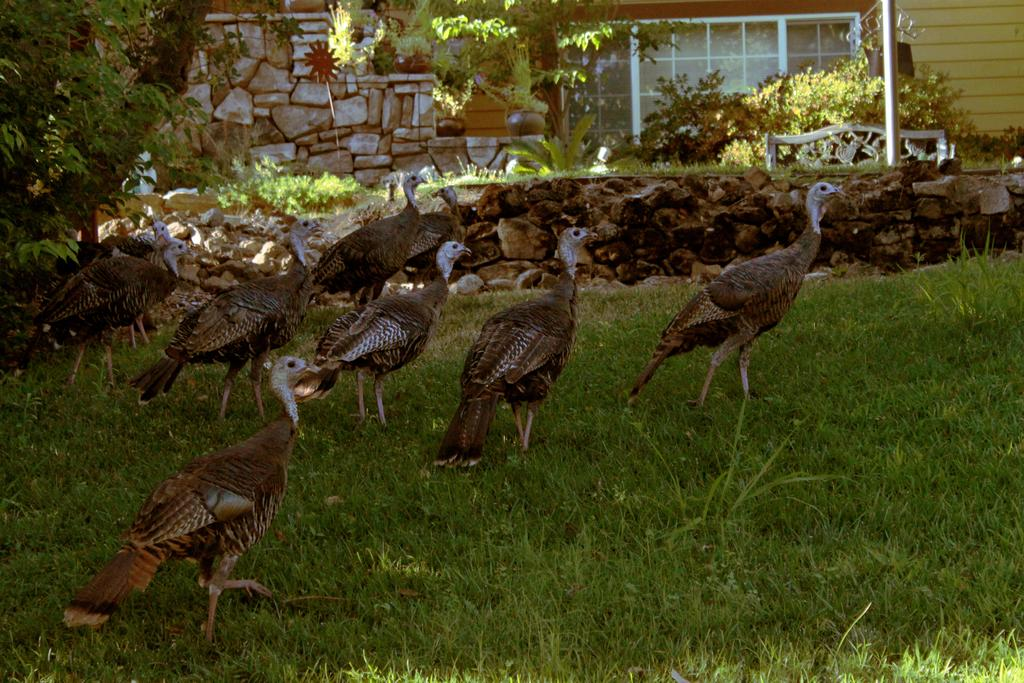What type of animals can be seen in the image? There are many birds in the image. What other elements are present in the image besides the birds? There are plants, a pole, plants and grass, stones, and a window in the image. Can you describe the plants and grass in the image? Yes, there are plants and grass in the image. What is the purpose of the pole in the image? The purpose of the pole is not specified in the image. What is the title of the book that the birds are reading in the image? There is no book or reading activity depicted in the image. 